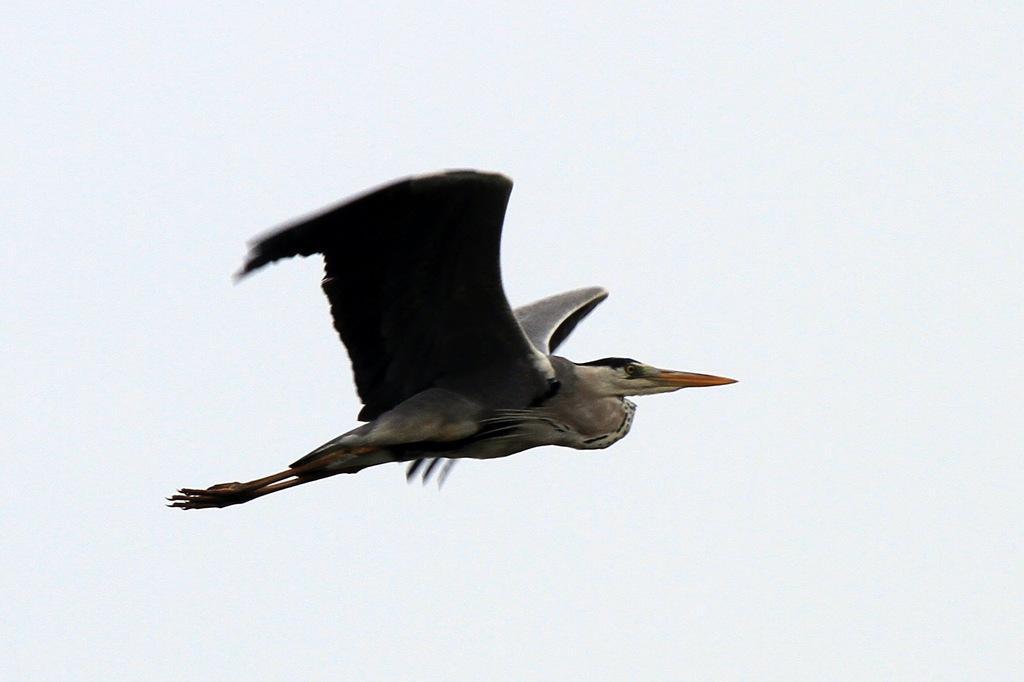Describe this image in one or two sentences. In the center of the image we can see a bird flying. 